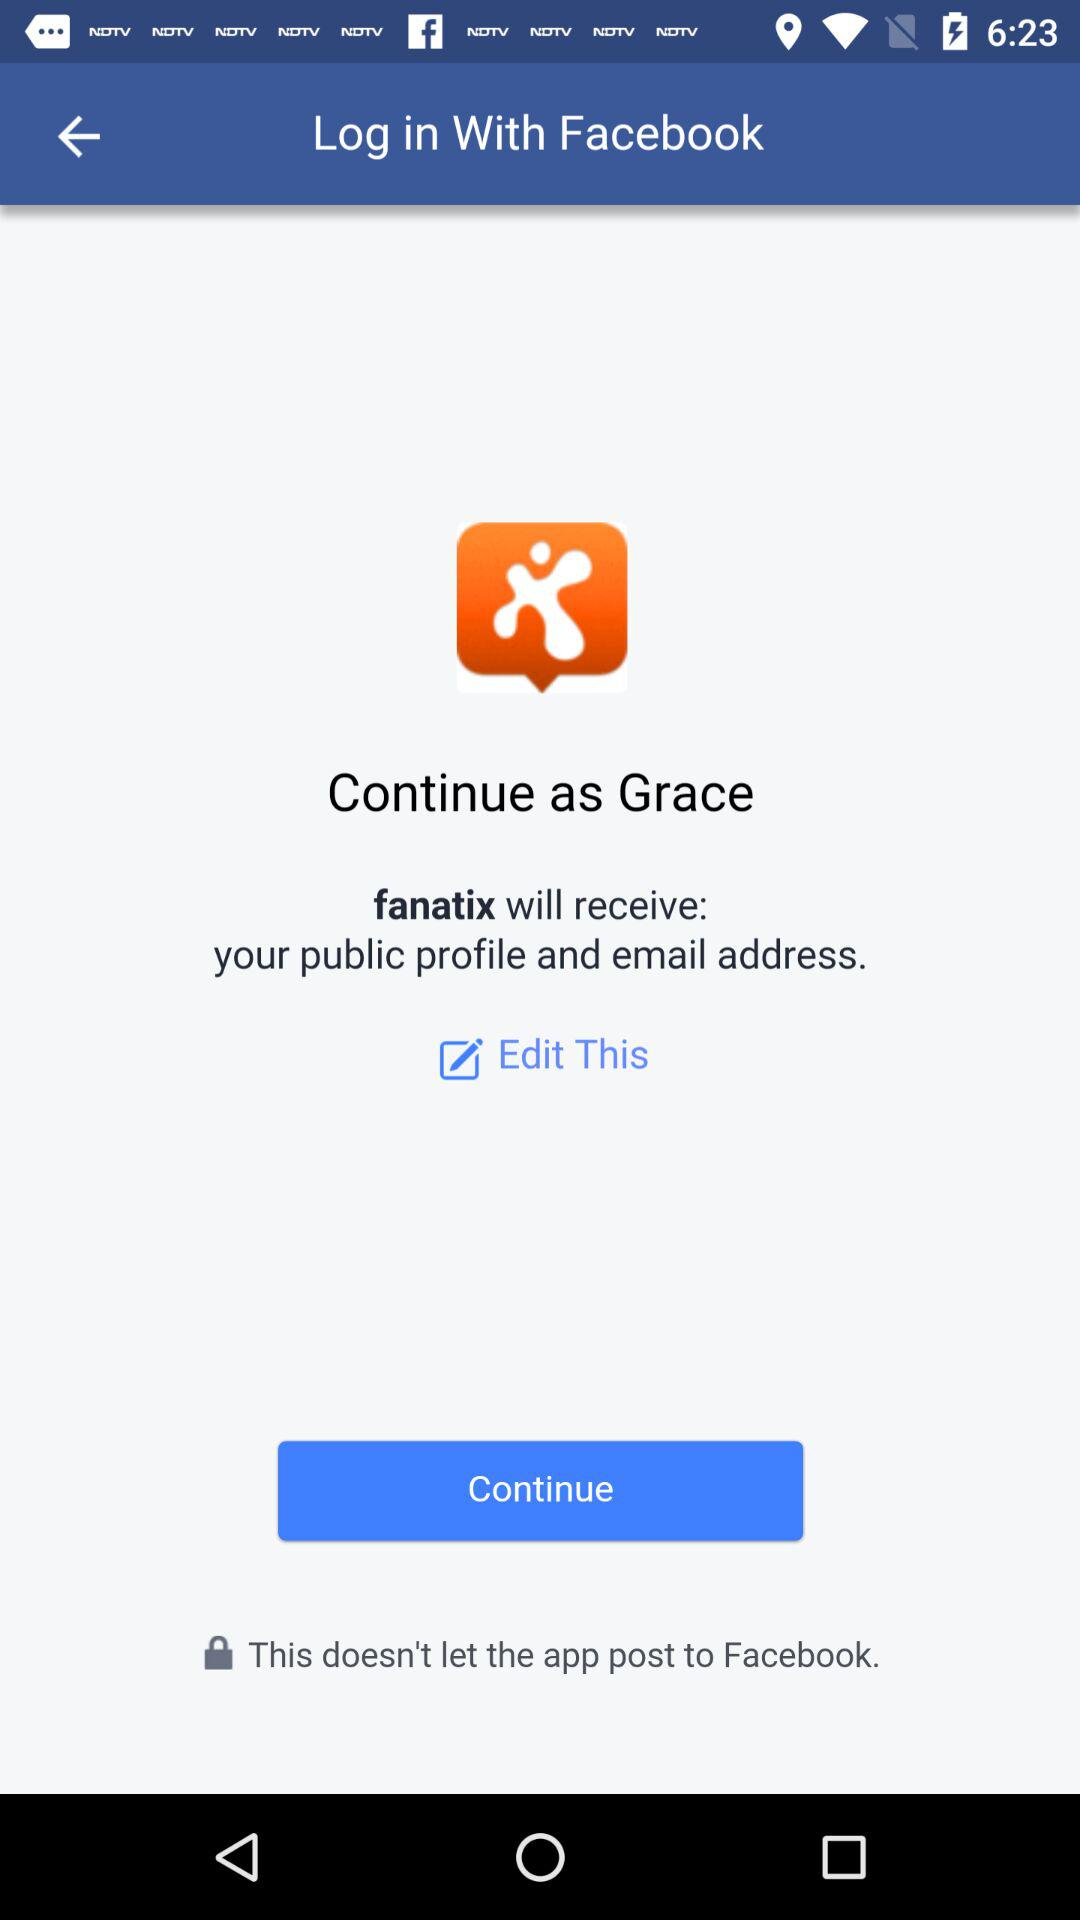What is the name of the user? The name of the user is "Grace". 